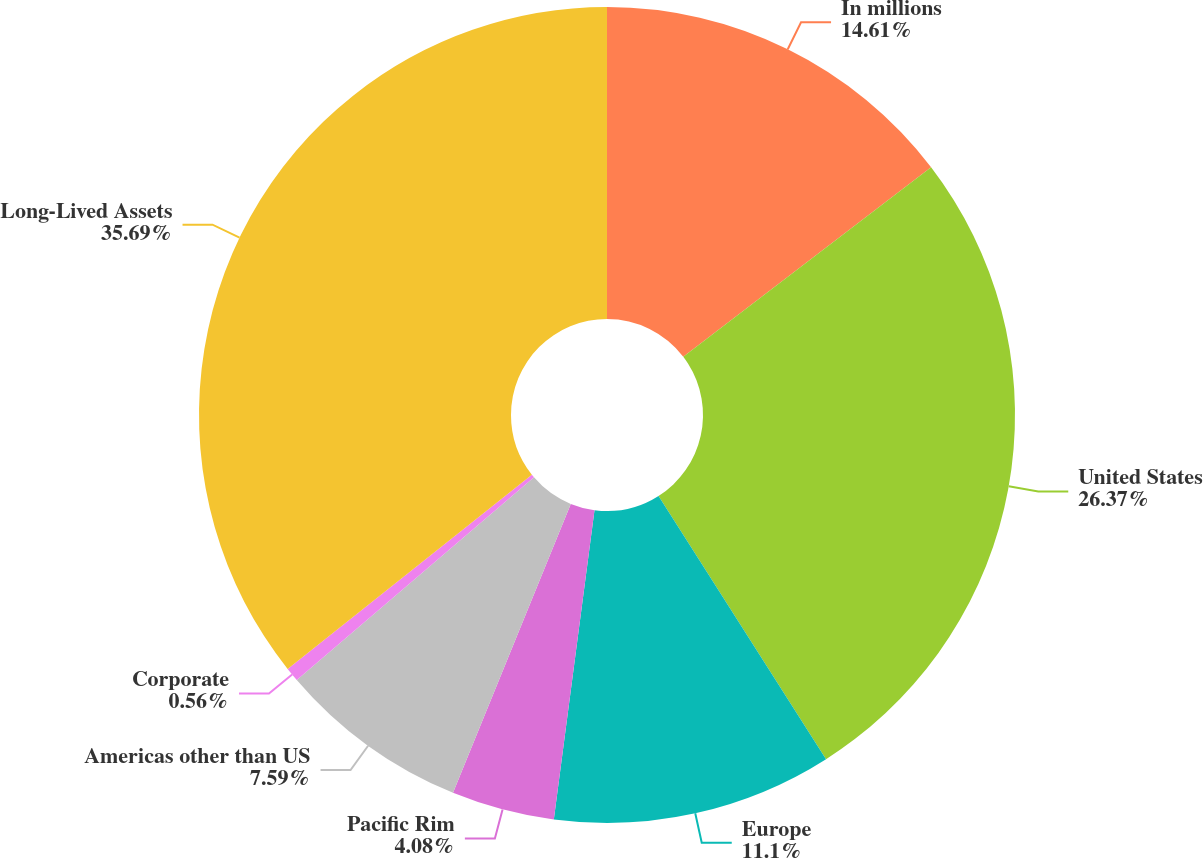<chart> <loc_0><loc_0><loc_500><loc_500><pie_chart><fcel>In millions<fcel>United States<fcel>Europe<fcel>Pacific Rim<fcel>Americas other than US<fcel>Corporate<fcel>Long-Lived Assets<nl><fcel>14.61%<fcel>26.37%<fcel>11.1%<fcel>4.08%<fcel>7.59%<fcel>0.56%<fcel>35.69%<nl></chart> 